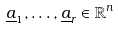Convert formula to latex. <formula><loc_0><loc_0><loc_500><loc_500>\underline { a } _ { 1 } , \dots , \underline { a } _ { r } \in \mathbb { R } ^ { n }</formula> 